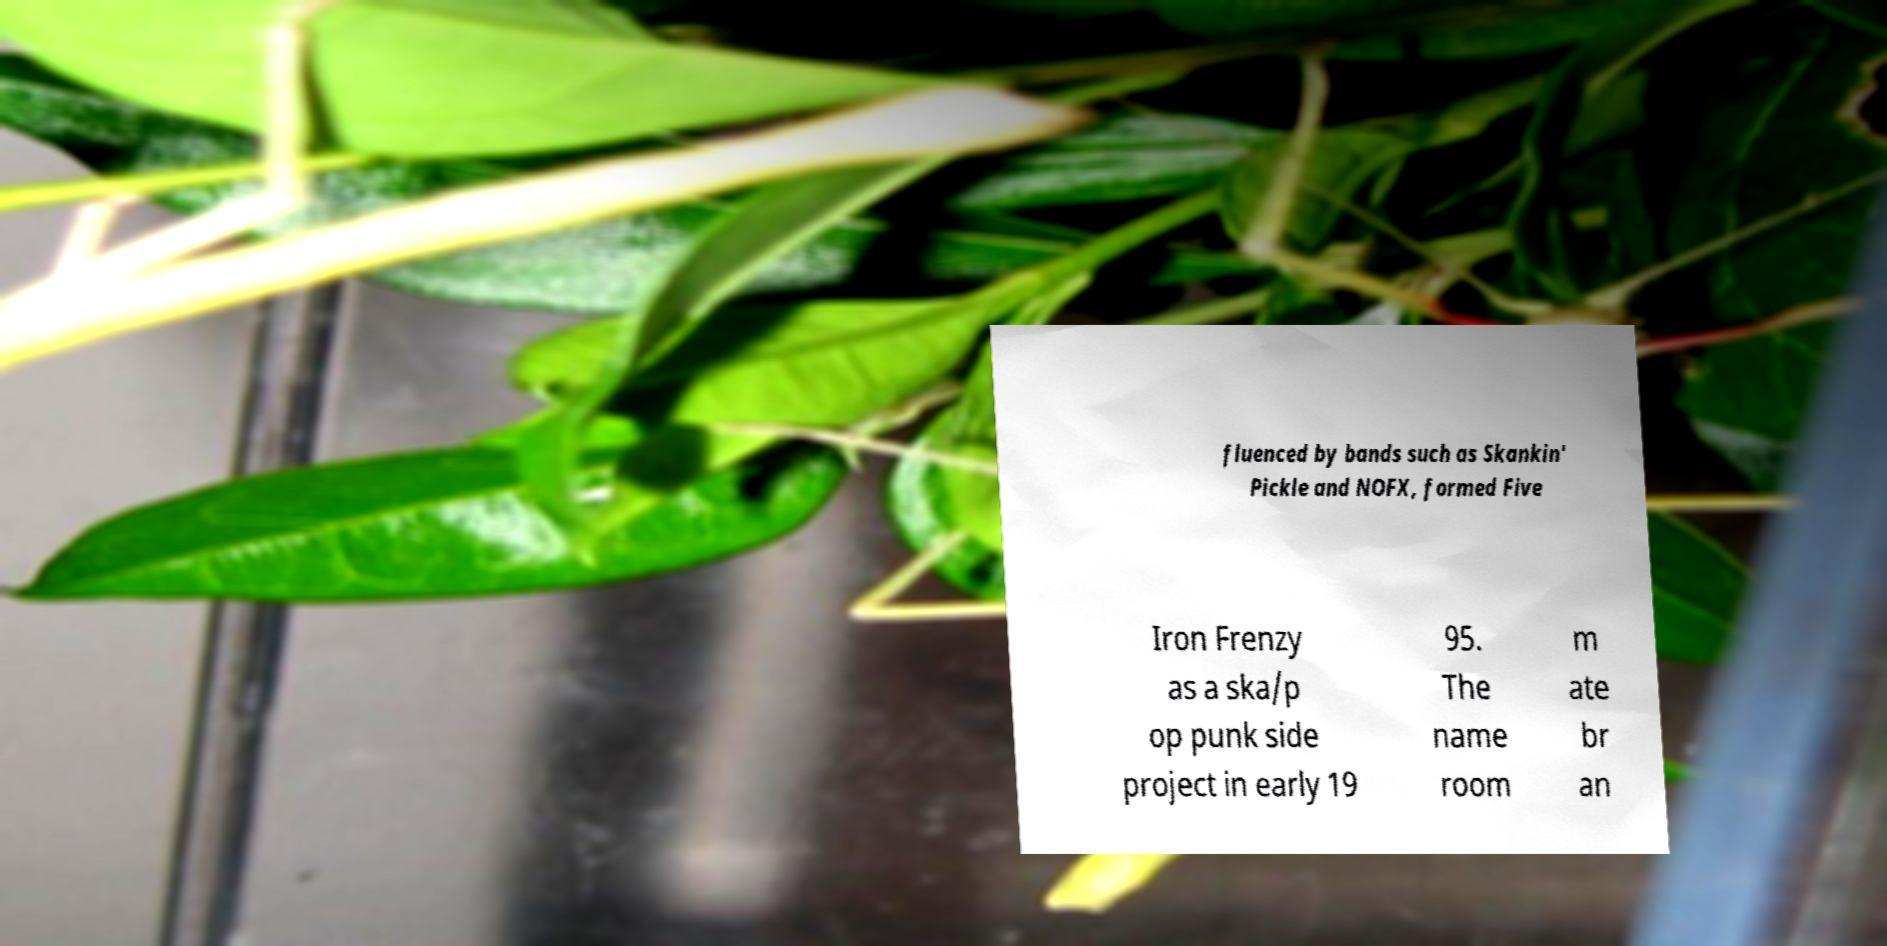Could you assist in decoding the text presented in this image and type it out clearly? fluenced by bands such as Skankin' Pickle and NOFX, formed Five Iron Frenzy as a ska/p op punk side project in early 19 95. The name room m ate br an 